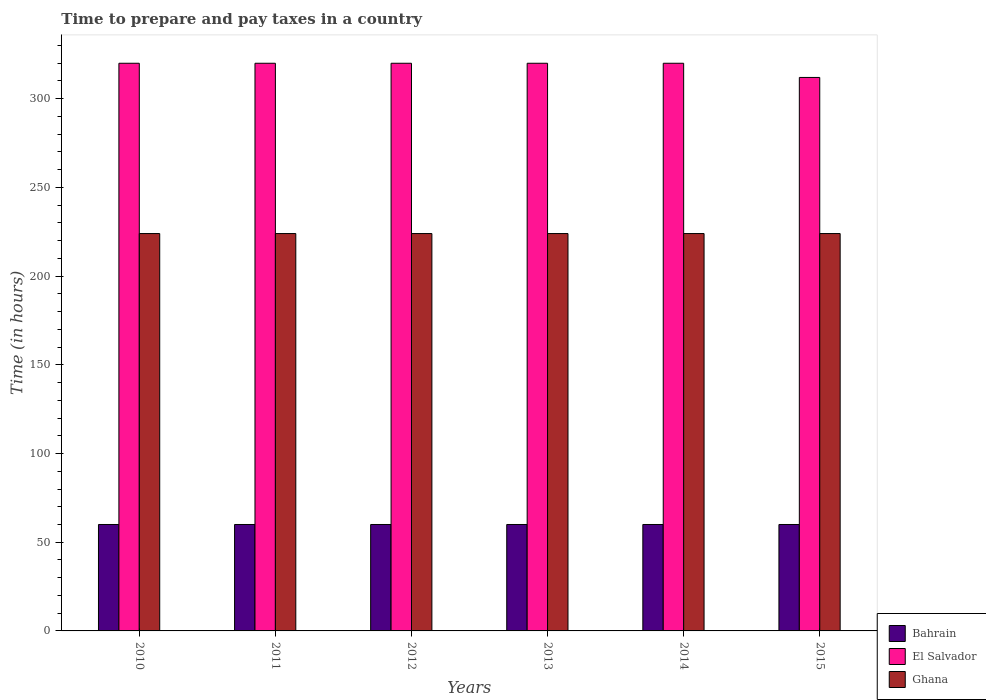Are the number of bars per tick equal to the number of legend labels?
Ensure brevity in your answer.  Yes. What is the label of the 3rd group of bars from the left?
Ensure brevity in your answer.  2012. What is the number of hours required to prepare and pay taxes in Bahrain in 2011?
Your response must be concise. 60. Across all years, what is the maximum number of hours required to prepare and pay taxes in Ghana?
Keep it short and to the point. 224. Across all years, what is the minimum number of hours required to prepare and pay taxes in El Salvador?
Provide a succinct answer. 312. In which year was the number of hours required to prepare and pay taxes in El Salvador minimum?
Your answer should be very brief. 2015. What is the total number of hours required to prepare and pay taxes in El Salvador in the graph?
Your response must be concise. 1912. What is the difference between the number of hours required to prepare and pay taxes in Ghana in 2010 and the number of hours required to prepare and pay taxes in Bahrain in 2013?
Ensure brevity in your answer.  164. What is the average number of hours required to prepare and pay taxes in El Salvador per year?
Make the answer very short. 318.67. In the year 2012, what is the difference between the number of hours required to prepare and pay taxes in El Salvador and number of hours required to prepare and pay taxes in Ghana?
Offer a terse response. 96. In how many years, is the number of hours required to prepare and pay taxes in El Salvador greater than 20 hours?
Your response must be concise. 6. What is the ratio of the number of hours required to prepare and pay taxes in Bahrain in 2011 to that in 2013?
Ensure brevity in your answer.  1. Is the difference between the number of hours required to prepare and pay taxes in El Salvador in 2012 and 2013 greater than the difference between the number of hours required to prepare and pay taxes in Ghana in 2012 and 2013?
Your answer should be compact. No. What is the difference between the highest and the lowest number of hours required to prepare and pay taxes in Ghana?
Make the answer very short. 0. Is the sum of the number of hours required to prepare and pay taxes in Bahrain in 2011 and 2015 greater than the maximum number of hours required to prepare and pay taxes in Ghana across all years?
Offer a terse response. No. What does the 1st bar from the left in 2014 represents?
Your answer should be very brief. Bahrain. What does the 2nd bar from the right in 2015 represents?
Offer a terse response. El Salvador. How many bars are there?
Provide a short and direct response. 18. Are all the bars in the graph horizontal?
Ensure brevity in your answer.  No. How many years are there in the graph?
Keep it short and to the point. 6. What is the difference between two consecutive major ticks on the Y-axis?
Give a very brief answer. 50. Does the graph contain any zero values?
Your answer should be compact. No. Where does the legend appear in the graph?
Your answer should be very brief. Bottom right. How many legend labels are there?
Make the answer very short. 3. How are the legend labels stacked?
Keep it short and to the point. Vertical. What is the title of the graph?
Ensure brevity in your answer.  Time to prepare and pay taxes in a country. Does "Bhutan" appear as one of the legend labels in the graph?
Give a very brief answer. No. What is the label or title of the X-axis?
Provide a short and direct response. Years. What is the label or title of the Y-axis?
Your answer should be compact. Time (in hours). What is the Time (in hours) in Bahrain in 2010?
Your answer should be compact. 60. What is the Time (in hours) in El Salvador in 2010?
Keep it short and to the point. 320. What is the Time (in hours) of Ghana in 2010?
Ensure brevity in your answer.  224. What is the Time (in hours) of El Salvador in 2011?
Give a very brief answer. 320. What is the Time (in hours) of Ghana in 2011?
Provide a short and direct response. 224. What is the Time (in hours) of Bahrain in 2012?
Provide a short and direct response. 60. What is the Time (in hours) in El Salvador in 2012?
Provide a short and direct response. 320. What is the Time (in hours) of Ghana in 2012?
Offer a terse response. 224. What is the Time (in hours) of El Salvador in 2013?
Provide a succinct answer. 320. What is the Time (in hours) in Ghana in 2013?
Provide a short and direct response. 224. What is the Time (in hours) in El Salvador in 2014?
Offer a terse response. 320. What is the Time (in hours) of Ghana in 2014?
Your answer should be compact. 224. What is the Time (in hours) in Bahrain in 2015?
Give a very brief answer. 60. What is the Time (in hours) in El Salvador in 2015?
Your answer should be very brief. 312. What is the Time (in hours) in Ghana in 2015?
Make the answer very short. 224. Across all years, what is the maximum Time (in hours) of El Salvador?
Your response must be concise. 320. Across all years, what is the maximum Time (in hours) in Ghana?
Your response must be concise. 224. Across all years, what is the minimum Time (in hours) of El Salvador?
Provide a succinct answer. 312. Across all years, what is the minimum Time (in hours) in Ghana?
Your answer should be compact. 224. What is the total Time (in hours) of Bahrain in the graph?
Provide a short and direct response. 360. What is the total Time (in hours) of El Salvador in the graph?
Keep it short and to the point. 1912. What is the total Time (in hours) of Ghana in the graph?
Provide a succinct answer. 1344. What is the difference between the Time (in hours) of Bahrain in 2010 and that in 2011?
Give a very brief answer. 0. What is the difference between the Time (in hours) of El Salvador in 2010 and that in 2011?
Your answer should be very brief. 0. What is the difference between the Time (in hours) of Bahrain in 2010 and that in 2012?
Your answer should be compact. 0. What is the difference between the Time (in hours) in El Salvador in 2010 and that in 2012?
Your answer should be compact. 0. What is the difference between the Time (in hours) of Bahrain in 2010 and that in 2013?
Give a very brief answer. 0. What is the difference between the Time (in hours) in Bahrain in 2010 and that in 2014?
Give a very brief answer. 0. What is the difference between the Time (in hours) in El Salvador in 2010 and that in 2014?
Provide a short and direct response. 0. What is the difference between the Time (in hours) in Bahrain in 2011 and that in 2012?
Your response must be concise. 0. What is the difference between the Time (in hours) of El Salvador in 2011 and that in 2012?
Offer a terse response. 0. What is the difference between the Time (in hours) of Ghana in 2011 and that in 2012?
Offer a very short reply. 0. What is the difference between the Time (in hours) in Bahrain in 2011 and that in 2013?
Ensure brevity in your answer.  0. What is the difference between the Time (in hours) in El Salvador in 2011 and that in 2013?
Provide a succinct answer. 0. What is the difference between the Time (in hours) of El Salvador in 2011 and that in 2014?
Provide a succinct answer. 0. What is the difference between the Time (in hours) of Ghana in 2011 and that in 2014?
Provide a succinct answer. 0. What is the difference between the Time (in hours) in Bahrain in 2011 and that in 2015?
Keep it short and to the point. 0. What is the difference between the Time (in hours) of El Salvador in 2012 and that in 2013?
Provide a short and direct response. 0. What is the difference between the Time (in hours) in El Salvador in 2012 and that in 2014?
Make the answer very short. 0. What is the difference between the Time (in hours) in Bahrain in 2012 and that in 2015?
Your response must be concise. 0. What is the difference between the Time (in hours) of El Salvador in 2012 and that in 2015?
Make the answer very short. 8. What is the difference between the Time (in hours) in El Salvador in 2013 and that in 2015?
Your answer should be compact. 8. What is the difference between the Time (in hours) of Ghana in 2013 and that in 2015?
Your response must be concise. 0. What is the difference between the Time (in hours) of El Salvador in 2014 and that in 2015?
Make the answer very short. 8. What is the difference between the Time (in hours) in Ghana in 2014 and that in 2015?
Give a very brief answer. 0. What is the difference between the Time (in hours) of Bahrain in 2010 and the Time (in hours) of El Salvador in 2011?
Offer a very short reply. -260. What is the difference between the Time (in hours) in Bahrain in 2010 and the Time (in hours) in Ghana in 2011?
Make the answer very short. -164. What is the difference between the Time (in hours) of El Salvador in 2010 and the Time (in hours) of Ghana in 2011?
Ensure brevity in your answer.  96. What is the difference between the Time (in hours) of Bahrain in 2010 and the Time (in hours) of El Salvador in 2012?
Keep it short and to the point. -260. What is the difference between the Time (in hours) in Bahrain in 2010 and the Time (in hours) in Ghana in 2012?
Give a very brief answer. -164. What is the difference between the Time (in hours) in El Salvador in 2010 and the Time (in hours) in Ghana in 2012?
Provide a short and direct response. 96. What is the difference between the Time (in hours) of Bahrain in 2010 and the Time (in hours) of El Salvador in 2013?
Your response must be concise. -260. What is the difference between the Time (in hours) of Bahrain in 2010 and the Time (in hours) of Ghana in 2013?
Offer a very short reply. -164. What is the difference between the Time (in hours) of El Salvador in 2010 and the Time (in hours) of Ghana in 2013?
Keep it short and to the point. 96. What is the difference between the Time (in hours) of Bahrain in 2010 and the Time (in hours) of El Salvador in 2014?
Ensure brevity in your answer.  -260. What is the difference between the Time (in hours) in Bahrain in 2010 and the Time (in hours) in Ghana in 2014?
Make the answer very short. -164. What is the difference between the Time (in hours) of El Salvador in 2010 and the Time (in hours) of Ghana in 2014?
Ensure brevity in your answer.  96. What is the difference between the Time (in hours) in Bahrain in 2010 and the Time (in hours) in El Salvador in 2015?
Provide a short and direct response. -252. What is the difference between the Time (in hours) of Bahrain in 2010 and the Time (in hours) of Ghana in 2015?
Ensure brevity in your answer.  -164. What is the difference between the Time (in hours) in El Salvador in 2010 and the Time (in hours) in Ghana in 2015?
Keep it short and to the point. 96. What is the difference between the Time (in hours) of Bahrain in 2011 and the Time (in hours) of El Salvador in 2012?
Your answer should be compact. -260. What is the difference between the Time (in hours) of Bahrain in 2011 and the Time (in hours) of Ghana in 2012?
Give a very brief answer. -164. What is the difference between the Time (in hours) of El Salvador in 2011 and the Time (in hours) of Ghana in 2012?
Keep it short and to the point. 96. What is the difference between the Time (in hours) of Bahrain in 2011 and the Time (in hours) of El Salvador in 2013?
Your answer should be very brief. -260. What is the difference between the Time (in hours) of Bahrain in 2011 and the Time (in hours) of Ghana in 2013?
Give a very brief answer. -164. What is the difference between the Time (in hours) of El Salvador in 2011 and the Time (in hours) of Ghana in 2013?
Give a very brief answer. 96. What is the difference between the Time (in hours) in Bahrain in 2011 and the Time (in hours) in El Salvador in 2014?
Your response must be concise. -260. What is the difference between the Time (in hours) of Bahrain in 2011 and the Time (in hours) of Ghana in 2014?
Provide a succinct answer. -164. What is the difference between the Time (in hours) in El Salvador in 2011 and the Time (in hours) in Ghana in 2014?
Provide a succinct answer. 96. What is the difference between the Time (in hours) of Bahrain in 2011 and the Time (in hours) of El Salvador in 2015?
Give a very brief answer. -252. What is the difference between the Time (in hours) of Bahrain in 2011 and the Time (in hours) of Ghana in 2015?
Your answer should be very brief. -164. What is the difference between the Time (in hours) of El Salvador in 2011 and the Time (in hours) of Ghana in 2015?
Ensure brevity in your answer.  96. What is the difference between the Time (in hours) in Bahrain in 2012 and the Time (in hours) in El Salvador in 2013?
Ensure brevity in your answer.  -260. What is the difference between the Time (in hours) of Bahrain in 2012 and the Time (in hours) of Ghana in 2013?
Your answer should be very brief. -164. What is the difference between the Time (in hours) in El Salvador in 2012 and the Time (in hours) in Ghana in 2013?
Your answer should be compact. 96. What is the difference between the Time (in hours) of Bahrain in 2012 and the Time (in hours) of El Salvador in 2014?
Provide a short and direct response. -260. What is the difference between the Time (in hours) of Bahrain in 2012 and the Time (in hours) of Ghana in 2014?
Make the answer very short. -164. What is the difference between the Time (in hours) of El Salvador in 2012 and the Time (in hours) of Ghana in 2014?
Give a very brief answer. 96. What is the difference between the Time (in hours) in Bahrain in 2012 and the Time (in hours) in El Salvador in 2015?
Provide a succinct answer. -252. What is the difference between the Time (in hours) in Bahrain in 2012 and the Time (in hours) in Ghana in 2015?
Provide a succinct answer. -164. What is the difference between the Time (in hours) in El Salvador in 2012 and the Time (in hours) in Ghana in 2015?
Ensure brevity in your answer.  96. What is the difference between the Time (in hours) of Bahrain in 2013 and the Time (in hours) of El Salvador in 2014?
Your answer should be compact. -260. What is the difference between the Time (in hours) in Bahrain in 2013 and the Time (in hours) in Ghana in 2014?
Make the answer very short. -164. What is the difference between the Time (in hours) of El Salvador in 2013 and the Time (in hours) of Ghana in 2014?
Offer a very short reply. 96. What is the difference between the Time (in hours) in Bahrain in 2013 and the Time (in hours) in El Salvador in 2015?
Provide a succinct answer. -252. What is the difference between the Time (in hours) of Bahrain in 2013 and the Time (in hours) of Ghana in 2015?
Your response must be concise. -164. What is the difference between the Time (in hours) of El Salvador in 2013 and the Time (in hours) of Ghana in 2015?
Provide a succinct answer. 96. What is the difference between the Time (in hours) in Bahrain in 2014 and the Time (in hours) in El Salvador in 2015?
Your answer should be very brief. -252. What is the difference between the Time (in hours) of Bahrain in 2014 and the Time (in hours) of Ghana in 2015?
Ensure brevity in your answer.  -164. What is the difference between the Time (in hours) of El Salvador in 2014 and the Time (in hours) of Ghana in 2015?
Ensure brevity in your answer.  96. What is the average Time (in hours) in Bahrain per year?
Offer a terse response. 60. What is the average Time (in hours) of El Salvador per year?
Offer a very short reply. 318.67. What is the average Time (in hours) of Ghana per year?
Your response must be concise. 224. In the year 2010, what is the difference between the Time (in hours) in Bahrain and Time (in hours) in El Salvador?
Your answer should be compact. -260. In the year 2010, what is the difference between the Time (in hours) in Bahrain and Time (in hours) in Ghana?
Provide a succinct answer. -164. In the year 2010, what is the difference between the Time (in hours) in El Salvador and Time (in hours) in Ghana?
Your response must be concise. 96. In the year 2011, what is the difference between the Time (in hours) of Bahrain and Time (in hours) of El Salvador?
Give a very brief answer. -260. In the year 2011, what is the difference between the Time (in hours) of Bahrain and Time (in hours) of Ghana?
Give a very brief answer. -164. In the year 2011, what is the difference between the Time (in hours) in El Salvador and Time (in hours) in Ghana?
Offer a very short reply. 96. In the year 2012, what is the difference between the Time (in hours) of Bahrain and Time (in hours) of El Salvador?
Offer a very short reply. -260. In the year 2012, what is the difference between the Time (in hours) in Bahrain and Time (in hours) in Ghana?
Your answer should be very brief. -164. In the year 2012, what is the difference between the Time (in hours) of El Salvador and Time (in hours) of Ghana?
Your response must be concise. 96. In the year 2013, what is the difference between the Time (in hours) of Bahrain and Time (in hours) of El Salvador?
Give a very brief answer. -260. In the year 2013, what is the difference between the Time (in hours) in Bahrain and Time (in hours) in Ghana?
Make the answer very short. -164. In the year 2013, what is the difference between the Time (in hours) in El Salvador and Time (in hours) in Ghana?
Give a very brief answer. 96. In the year 2014, what is the difference between the Time (in hours) of Bahrain and Time (in hours) of El Salvador?
Provide a short and direct response. -260. In the year 2014, what is the difference between the Time (in hours) of Bahrain and Time (in hours) of Ghana?
Provide a succinct answer. -164. In the year 2014, what is the difference between the Time (in hours) of El Salvador and Time (in hours) of Ghana?
Offer a terse response. 96. In the year 2015, what is the difference between the Time (in hours) in Bahrain and Time (in hours) in El Salvador?
Provide a short and direct response. -252. In the year 2015, what is the difference between the Time (in hours) of Bahrain and Time (in hours) of Ghana?
Make the answer very short. -164. What is the ratio of the Time (in hours) in Bahrain in 2010 to that in 2011?
Give a very brief answer. 1. What is the ratio of the Time (in hours) of El Salvador in 2010 to that in 2011?
Ensure brevity in your answer.  1. What is the ratio of the Time (in hours) of Bahrain in 2010 to that in 2013?
Offer a terse response. 1. What is the ratio of the Time (in hours) of El Salvador in 2010 to that in 2014?
Your answer should be very brief. 1. What is the ratio of the Time (in hours) of Ghana in 2010 to that in 2014?
Keep it short and to the point. 1. What is the ratio of the Time (in hours) of El Salvador in 2010 to that in 2015?
Your response must be concise. 1.03. What is the ratio of the Time (in hours) of Bahrain in 2011 to that in 2012?
Ensure brevity in your answer.  1. What is the ratio of the Time (in hours) in El Salvador in 2011 to that in 2012?
Your response must be concise. 1. What is the ratio of the Time (in hours) in Ghana in 2011 to that in 2013?
Make the answer very short. 1. What is the ratio of the Time (in hours) of Bahrain in 2011 to that in 2014?
Provide a short and direct response. 1. What is the ratio of the Time (in hours) of Ghana in 2011 to that in 2014?
Provide a short and direct response. 1. What is the ratio of the Time (in hours) in Bahrain in 2011 to that in 2015?
Your answer should be very brief. 1. What is the ratio of the Time (in hours) of El Salvador in 2011 to that in 2015?
Your response must be concise. 1.03. What is the ratio of the Time (in hours) of Bahrain in 2012 to that in 2013?
Your answer should be very brief. 1. What is the ratio of the Time (in hours) of El Salvador in 2012 to that in 2013?
Give a very brief answer. 1. What is the ratio of the Time (in hours) of Ghana in 2012 to that in 2013?
Give a very brief answer. 1. What is the ratio of the Time (in hours) in Bahrain in 2012 to that in 2014?
Your response must be concise. 1. What is the ratio of the Time (in hours) of El Salvador in 2012 to that in 2015?
Offer a terse response. 1.03. What is the ratio of the Time (in hours) in Ghana in 2012 to that in 2015?
Ensure brevity in your answer.  1. What is the ratio of the Time (in hours) in Bahrain in 2013 to that in 2014?
Your response must be concise. 1. What is the ratio of the Time (in hours) of El Salvador in 2013 to that in 2014?
Provide a short and direct response. 1. What is the ratio of the Time (in hours) of Ghana in 2013 to that in 2014?
Your response must be concise. 1. What is the ratio of the Time (in hours) in El Salvador in 2013 to that in 2015?
Offer a terse response. 1.03. What is the ratio of the Time (in hours) of El Salvador in 2014 to that in 2015?
Your response must be concise. 1.03. What is the difference between the highest and the second highest Time (in hours) of Bahrain?
Make the answer very short. 0. What is the difference between the highest and the second highest Time (in hours) in El Salvador?
Provide a succinct answer. 0. What is the difference between the highest and the second highest Time (in hours) of Ghana?
Offer a terse response. 0. What is the difference between the highest and the lowest Time (in hours) of Bahrain?
Make the answer very short. 0. 